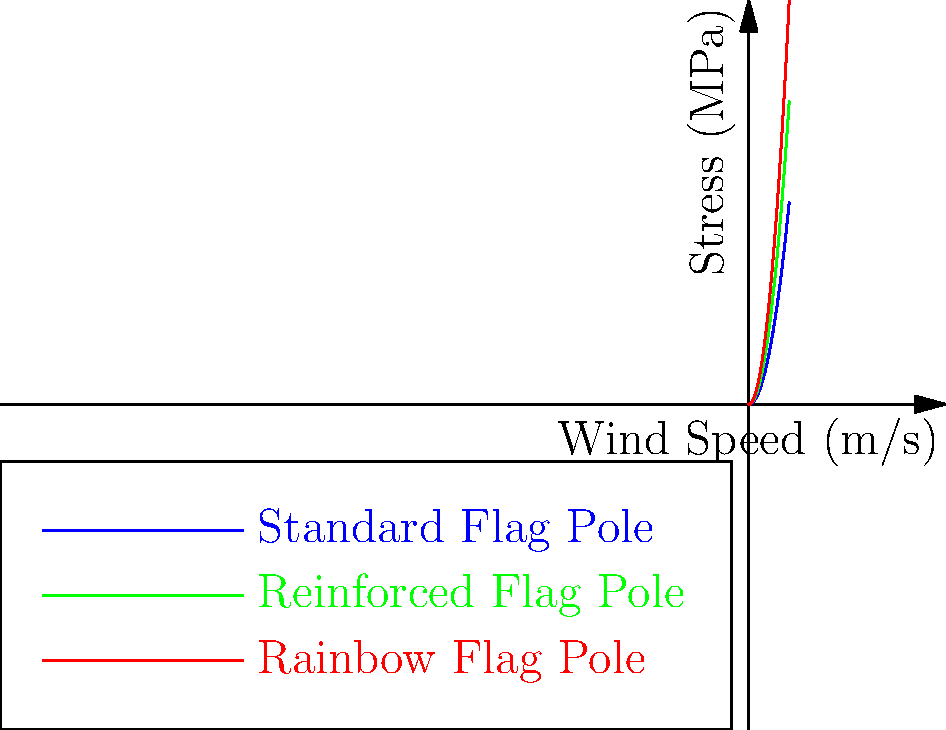As an activist working on LGBTQ+ rights, you're organizing a pride parade and need to ensure the safety of a large rainbow flag installation. The graph shows the stress distribution on different flag poles under various wind conditions. If the maximum allowable stress for the rainbow flag pole is 60 MPa, what is the maximum wind speed it can withstand safely? To solve this problem, we need to follow these steps:

1. Identify the curve representing the rainbow flag pole (red curve).
2. Recognize that the curve follows the equation $\sigma = x^2$, where $\sigma$ is stress in MPa and $x$ is wind speed in m/s.
3. Use the maximum allowable stress of 60 MPa in the equation:
   
   $60 = x^2$

4. Solve for $x$ by taking the square root of both sides:
   
   $x = \sqrt{60} = \sqrt{36 + 24} = \sqrt{36} + \sqrt{24} = 6 + 2\sqrt{6} \approx 7.75$ m/s

5. Round down to the nearest tenth for safety:
   
   $x \approx 7.7$ m/s

Therefore, the maximum wind speed the rainbow flag pole can withstand safely is approximately 7.7 m/s.
Answer: 7.7 m/s 